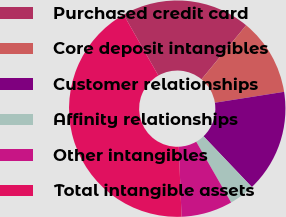Convert chart to OTSL. <chart><loc_0><loc_0><loc_500><loc_500><pie_chart><fcel>Purchased credit card<fcel>Core deposit intangibles<fcel>Customer relationships<fcel>Affinity relationships<fcel>Other intangibles<fcel>Total intangible assets<nl><fcel>19.24%<fcel>11.52%<fcel>15.38%<fcel>3.81%<fcel>7.66%<fcel>42.39%<nl></chart> 